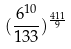<formula> <loc_0><loc_0><loc_500><loc_500>( \frac { 6 ^ { 1 0 } } { 1 3 3 } ) ^ { \frac { 4 1 1 } { 9 } }</formula> 